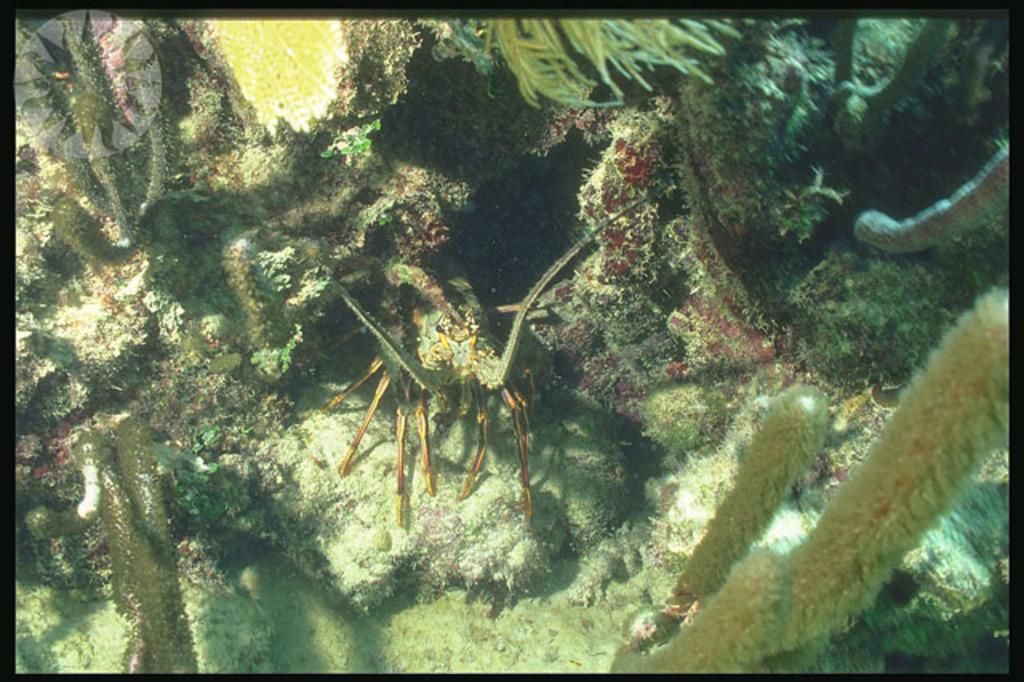What type of animal can be seen in the image? There is an insect in the image. What other creatures are present in the image? There are marine species in the image. Where are the insect and marine species located? The insect and marine species are inside the water. What type of prison can be seen in the image? There is no prison present in the image; it features an insect and marine species inside the water. How many legs does the carriage have in the image? There is no carriage present in the image, so it is not possible to determine the number of legs it might have. 